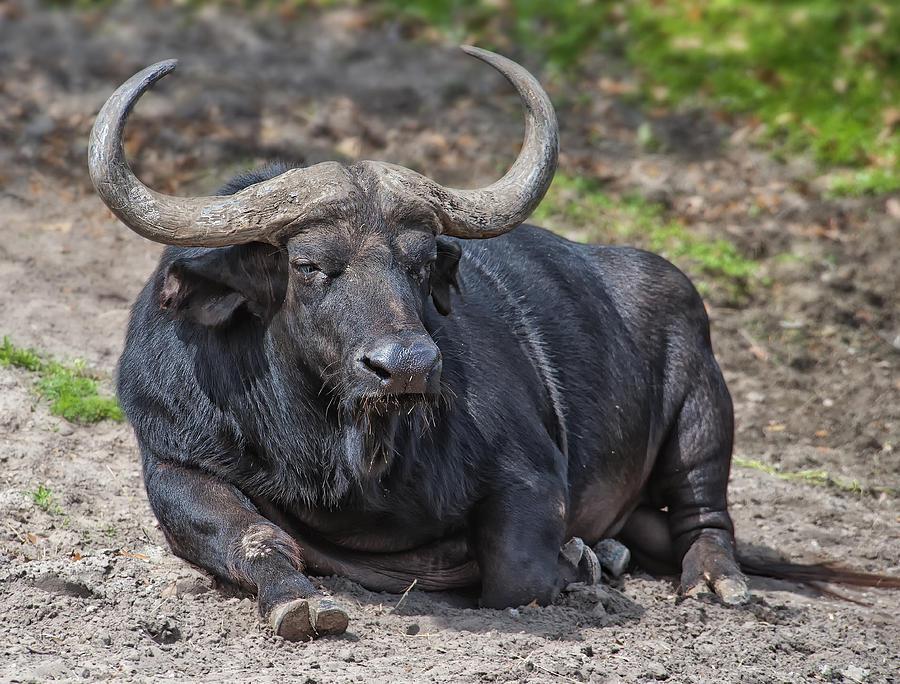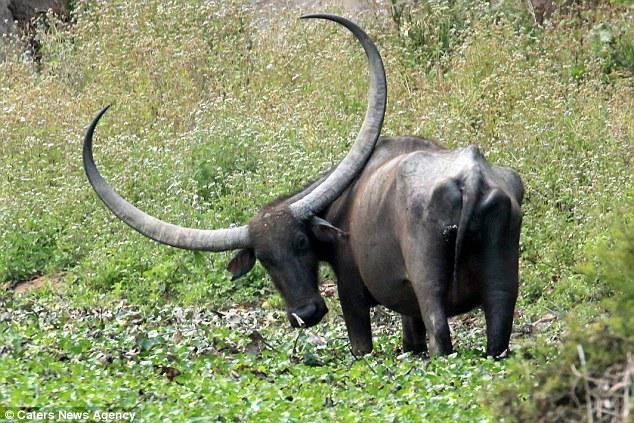The first image is the image on the left, the second image is the image on the right. Evaluate the accuracy of this statement regarding the images: "The animal in the image on the left is looking into the camera.". Is it true? Answer yes or no. No. 